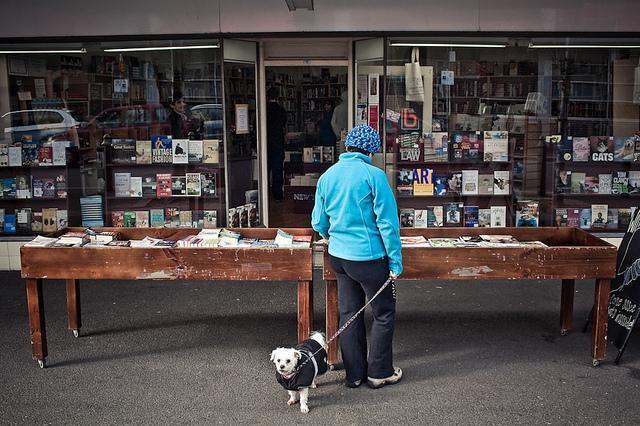How many black umbrella are there?
Give a very brief answer. 0. 